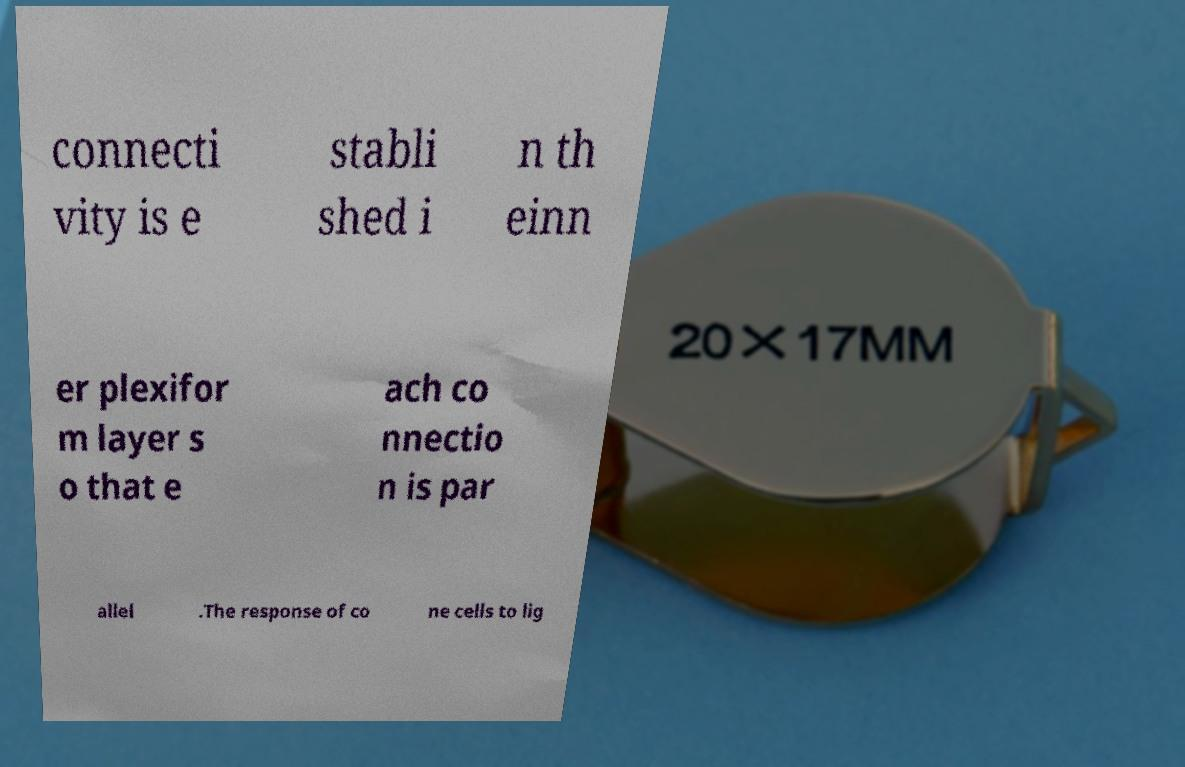What messages or text are displayed in this image? I need them in a readable, typed format. connecti vity is e stabli shed i n th einn er plexifor m layer s o that e ach co nnectio n is par allel .The response of co ne cells to lig 